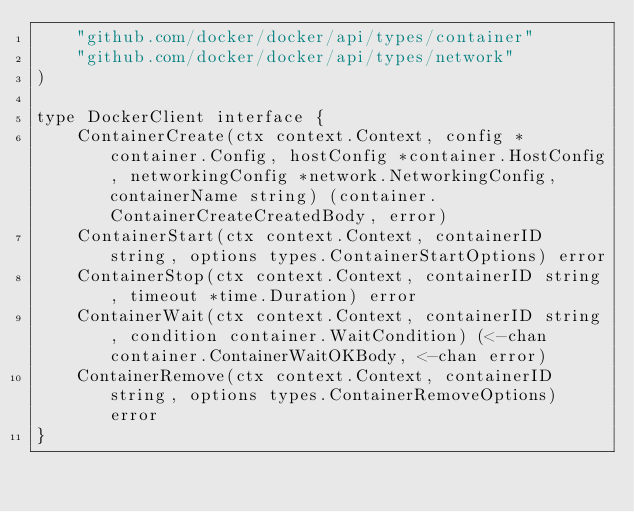<code> <loc_0><loc_0><loc_500><loc_500><_Go_>	"github.com/docker/docker/api/types/container"
	"github.com/docker/docker/api/types/network"
)

type DockerClient interface {
	ContainerCreate(ctx context.Context, config *container.Config, hostConfig *container.HostConfig, networkingConfig *network.NetworkingConfig, containerName string) (container.ContainerCreateCreatedBody, error)
	ContainerStart(ctx context.Context, containerID string, options types.ContainerStartOptions) error
	ContainerStop(ctx context.Context, containerID string, timeout *time.Duration) error
	ContainerWait(ctx context.Context, containerID string, condition container.WaitCondition) (<-chan container.ContainerWaitOKBody, <-chan error)
	ContainerRemove(ctx context.Context, containerID string, options types.ContainerRemoveOptions) error
}
</code> 